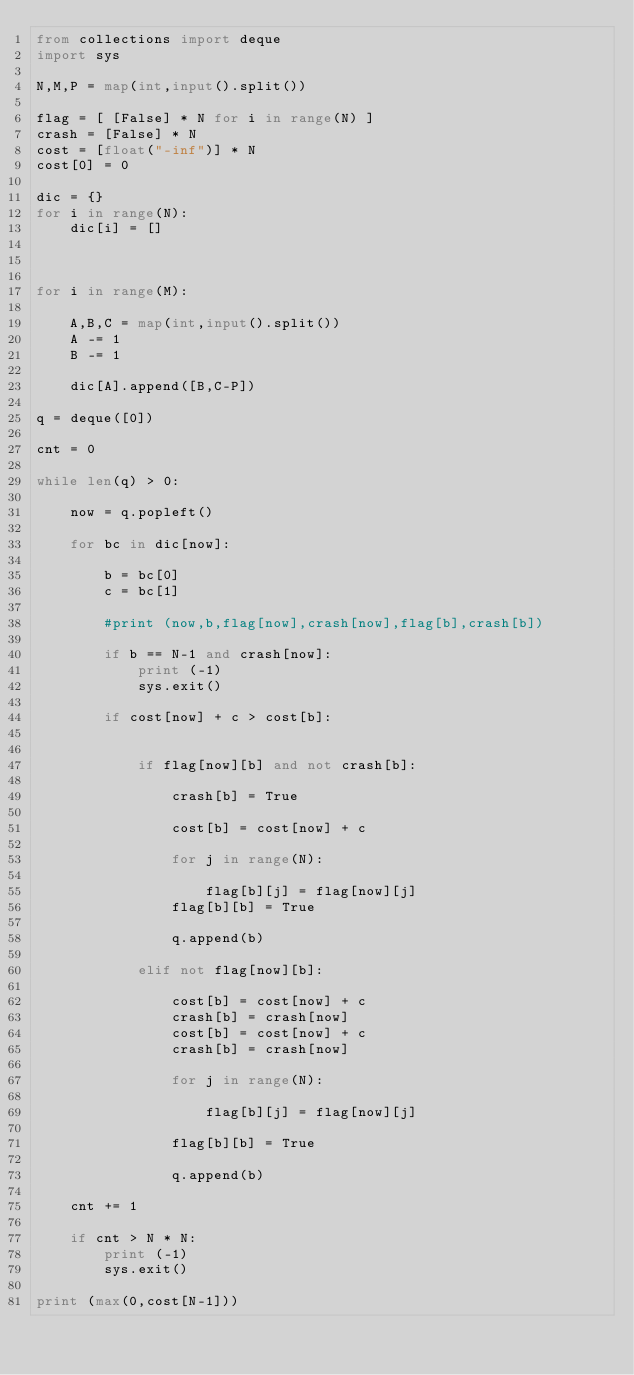Convert code to text. <code><loc_0><loc_0><loc_500><loc_500><_Python_>from collections import deque
import sys

N,M,P = map(int,input().split())

flag = [ [False] * N for i in range(N) ]
crash = [False] * N
cost = [float("-inf")] * N
cost[0] = 0

dic = {}
for i in range(N):
    dic[i] = []

    

for i in range(M):

    A,B,C = map(int,input().split())
    A -= 1
    B -= 1

    dic[A].append([B,C-P])

q = deque([0])

cnt = 0

while len(q) > 0:

    now = q.popleft()

    for bc in dic[now]:
    
        b = bc[0]
        c = bc[1]

        #print (now,b,flag[now],crash[now],flag[b],crash[b])

        if b == N-1 and crash[now]:
            print (-1)
            sys.exit()

        if cost[now] + c > cost[b]:


            if flag[now][b] and not crash[b]:

                crash[b] = True

                cost[b] = cost[now] + c

                for j in range(N):

                    flag[b][j] = flag[now][j]
                flag[b][b] = True
            
                q.append(b)

            elif not flag[now][b]:
                
                cost[b] = cost[now] + c
                crash[b] = crash[now]
                cost[b] = cost[now] + c
                crash[b] = crash[now]

                for j in range(N):

                    flag[b][j] = flag[now][j]
                    
                flag[b][b] = True

                q.append(b)

    cnt += 1

    if cnt > N * N:
        print (-1)
        sys.exit()

print (max(0,cost[N-1]))</code> 